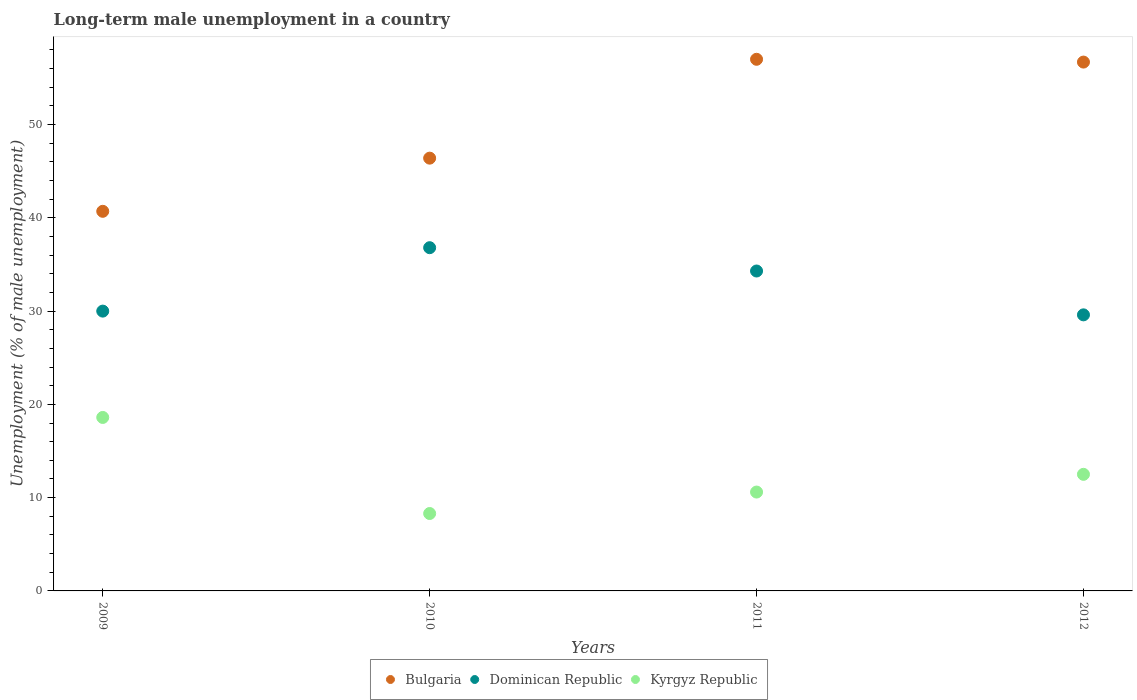How many different coloured dotlines are there?
Your answer should be compact. 3. Is the number of dotlines equal to the number of legend labels?
Provide a succinct answer. Yes. What is the percentage of long-term unemployed male population in Dominican Republic in 2012?
Provide a short and direct response. 29.6. Across all years, what is the maximum percentage of long-term unemployed male population in Kyrgyz Republic?
Your answer should be compact. 18.6. Across all years, what is the minimum percentage of long-term unemployed male population in Bulgaria?
Offer a very short reply. 40.7. In which year was the percentage of long-term unemployed male population in Kyrgyz Republic maximum?
Your answer should be very brief. 2009. In which year was the percentage of long-term unemployed male population in Kyrgyz Republic minimum?
Provide a short and direct response. 2010. What is the total percentage of long-term unemployed male population in Dominican Republic in the graph?
Your response must be concise. 130.7. What is the difference between the percentage of long-term unemployed male population in Dominican Republic in 2009 and that in 2012?
Make the answer very short. 0.4. What is the difference between the percentage of long-term unemployed male population in Dominican Republic in 2012 and the percentage of long-term unemployed male population in Bulgaria in 2009?
Provide a short and direct response. -11.1. What is the average percentage of long-term unemployed male population in Bulgaria per year?
Your answer should be compact. 50.2. In the year 2011, what is the difference between the percentage of long-term unemployed male population in Bulgaria and percentage of long-term unemployed male population in Kyrgyz Republic?
Your answer should be compact. 46.4. In how many years, is the percentage of long-term unemployed male population in Bulgaria greater than 14 %?
Offer a terse response. 4. What is the ratio of the percentage of long-term unemployed male population in Bulgaria in 2010 to that in 2011?
Your answer should be compact. 0.81. Is the percentage of long-term unemployed male population in Kyrgyz Republic in 2010 less than that in 2011?
Provide a succinct answer. Yes. Is the difference between the percentage of long-term unemployed male population in Bulgaria in 2010 and 2012 greater than the difference between the percentage of long-term unemployed male population in Kyrgyz Republic in 2010 and 2012?
Your response must be concise. No. What is the difference between the highest and the second highest percentage of long-term unemployed male population in Kyrgyz Republic?
Provide a succinct answer. 6.1. What is the difference between the highest and the lowest percentage of long-term unemployed male population in Kyrgyz Republic?
Provide a succinct answer. 10.3. Does the percentage of long-term unemployed male population in Kyrgyz Republic monotonically increase over the years?
Keep it short and to the point. No. Is the percentage of long-term unemployed male population in Dominican Republic strictly greater than the percentage of long-term unemployed male population in Kyrgyz Republic over the years?
Provide a succinct answer. Yes. Is the percentage of long-term unemployed male population in Dominican Republic strictly less than the percentage of long-term unemployed male population in Kyrgyz Republic over the years?
Make the answer very short. No. How many dotlines are there?
Give a very brief answer. 3. What is the difference between two consecutive major ticks on the Y-axis?
Offer a terse response. 10. Are the values on the major ticks of Y-axis written in scientific E-notation?
Your answer should be compact. No. Does the graph contain any zero values?
Your answer should be compact. No. Where does the legend appear in the graph?
Offer a very short reply. Bottom center. How many legend labels are there?
Your response must be concise. 3. How are the legend labels stacked?
Make the answer very short. Horizontal. What is the title of the graph?
Give a very brief answer. Long-term male unemployment in a country. Does "Senegal" appear as one of the legend labels in the graph?
Offer a very short reply. No. What is the label or title of the Y-axis?
Ensure brevity in your answer.  Unemployment (% of male unemployment). What is the Unemployment (% of male unemployment) of Bulgaria in 2009?
Make the answer very short. 40.7. What is the Unemployment (% of male unemployment) in Kyrgyz Republic in 2009?
Your answer should be very brief. 18.6. What is the Unemployment (% of male unemployment) of Bulgaria in 2010?
Provide a succinct answer. 46.4. What is the Unemployment (% of male unemployment) in Dominican Republic in 2010?
Offer a very short reply. 36.8. What is the Unemployment (% of male unemployment) in Kyrgyz Republic in 2010?
Your answer should be compact. 8.3. What is the Unemployment (% of male unemployment) in Dominican Republic in 2011?
Your response must be concise. 34.3. What is the Unemployment (% of male unemployment) in Kyrgyz Republic in 2011?
Provide a succinct answer. 10.6. What is the Unemployment (% of male unemployment) in Bulgaria in 2012?
Offer a very short reply. 56.7. What is the Unemployment (% of male unemployment) in Dominican Republic in 2012?
Keep it short and to the point. 29.6. Across all years, what is the maximum Unemployment (% of male unemployment) in Dominican Republic?
Offer a very short reply. 36.8. Across all years, what is the maximum Unemployment (% of male unemployment) in Kyrgyz Republic?
Offer a terse response. 18.6. Across all years, what is the minimum Unemployment (% of male unemployment) in Bulgaria?
Your answer should be compact. 40.7. Across all years, what is the minimum Unemployment (% of male unemployment) of Dominican Republic?
Your answer should be compact. 29.6. Across all years, what is the minimum Unemployment (% of male unemployment) in Kyrgyz Republic?
Your answer should be compact. 8.3. What is the total Unemployment (% of male unemployment) of Bulgaria in the graph?
Make the answer very short. 200.8. What is the total Unemployment (% of male unemployment) in Dominican Republic in the graph?
Ensure brevity in your answer.  130.7. What is the difference between the Unemployment (% of male unemployment) in Bulgaria in 2009 and that in 2010?
Ensure brevity in your answer.  -5.7. What is the difference between the Unemployment (% of male unemployment) in Kyrgyz Republic in 2009 and that in 2010?
Give a very brief answer. 10.3. What is the difference between the Unemployment (% of male unemployment) of Bulgaria in 2009 and that in 2011?
Your response must be concise. -16.3. What is the difference between the Unemployment (% of male unemployment) of Dominican Republic in 2009 and that in 2011?
Keep it short and to the point. -4.3. What is the difference between the Unemployment (% of male unemployment) in Bulgaria in 2009 and that in 2012?
Give a very brief answer. -16. What is the difference between the Unemployment (% of male unemployment) in Dominican Republic in 2009 and that in 2012?
Give a very brief answer. 0.4. What is the difference between the Unemployment (% of male unemployment) of Bulgaria in 2010 and that in 2011?
Offer a very short reply. -10.6. What is the difference between the Unemployment (% of male unemployment) of Dominican Republic in 2010 and that in 2012?
Your response must be concise. 7.2. What is the difference between the Unemployment (% of male unemployment) of Kyrgyz Republic in 2010 and that in 2012?
Ensure brevity in your answer.  -4.2. What is the difference between the Unemployment (% of male unemployment) of Kyrgyz Republic in 2011 and that in 2012?
Your answer should be compact. -1.9. What is the difference between the Unemployment (% of male unemployment) in Bulgaria in 2009 and the Unemployment (% of male unemployment) in Dominican Republic in 2010?
Offer a terse response. 3.9. What is the difference between the Unemployment (% of male unemployment) of Bulgaria in 2009 and the Unemployment (% of male unemployment) of Kyrgyz Republic in 2010?
Provide a succinct answer. 32.4. What is the difference between the Unemployment (% of male unemployment) of Dominican Republic in 2009 and the Unemployment (% of male unemployment) of Kyrgyz Republic in 2010?
Ensure brevity in your answer.  21.7. What is the difference between the Unemployment (% of male unemployment) of Bulgaria in 2009 and the Unemployment (% of male unemployment) of Dominican Republic in 2011?
Keep it short and to the point. 6.4. What is the difference between the Unemployment (% of male unemployment) in Bulgaria in 2009 and the Unemployment (% of male unemployment) in Kyrgyz Republic in 2011?
Give a very brief answer. 30.1. What is the difference between the Unemployment (% of male unemployment) of Dominican Republic in 2009 and the Unemployment (% of male unemployment) of Kyrgyz Republic in 2011?
Provide a succinct answer. 19.4. What is the difference between the Unemployment (% of male unemployment) in Bulgaria in 2009 and the Unemployment (% of male unemployment) in Dominican Republic in 2012?
Ensure brevity in your answer.  11.1. What is the difference between the Unemployment (% of male unemployment) in Bulgaria in 2009 and the Unemployment (% of male unemployment) in Kyrgyz Republic in 2012?
Offer a very short reply. 28.2. What is the difference between the Unemployment (% of male unemployment) in Bulgaria in 2010 and the Unemployment (% of male unemployment) in Dominican Republic in 2011?
Your answer should be very brief. 12.1. What is the difference between the Unemployment (% of male unemployment) of Bulgaria in 2010 and the Unemployment (% of male unemployment) of Kyrgyz Republic in 2011?
Your answer should be very brief. 35.8. What is the difference between the Unemployment (% of male unemployment) in Dominican Republic in 2010 and the Unemployment (% of male unemployment) in Kyrgyz Republic in 2011?
Ensure brevity in your answer.  26.2. What is the difference between the Unemployment (% of male unemployment) in Bulgaria in 2010 and the Unemployment (% of male unemployment) in Dominican Republic in 2012?
Keep it short and to the point. 16.8. What is the difference between the Unemployment (% of male unemployment) of Bulgaria in 2010 and the Unemployment (% of male unemployment) of Kyrgyz Republic in 2012?
Provide a succinct answer. 33.9. What is the difference between the Unemployment (% of male unemployment) in Dominican Republic in 2010 and the Unemployment (% of male unemployment) in Kyrgyz Republic in 2012?
Your response must be concise. 24.3. What is the difference between the Unemployment (% of male unemployment) in Bulgaria in 2011 and the Unemployment (% of male unemployment) in Dominican Republic in 2012?
Make the answer very short. 27.4. What is the difference between the Unemployment (% of male unemployment) in Bulgaria in 2011 and the Unemployment (% of male unemployment) in Kyrgyz Republic in 2012?
Your answer should be very brief. 44.5. What is the difference between the Unemployment (% of male unemployment) in Dominican Republic in 2011 and the Unemployment (% of male unemployment) in Kyrgyz Republic in 2012?
Ensure brevity in your answer.  21.8. What is the average Unemployment (% of male unemployment) in Bulgaria per year?
Make the answer very short. 50.2. What is the average Unemployment (% of male unemployment) in Dominican Republic per year?
Your response must be concise. 32.67. In the year 2009, what is the difference between the Unemployment (% of male unemployment) of Bulgaria and Unemployment (% of male unemployment) of Dominican Republic?
Your response must be concise. 10.7. In the year 2009, what is the difference between the Unemployment (% of male unemployment) of Bulgaria and Unemployment (% of male unemployment) of Kyrgyz Republic?
Your response must be concise. 22.1. In the year 2009, what is the difference between the Unemployment (% of male unemployment) in Dominican Republic and Unemployment (% of male unemployment) in Kyrgyz Republic?
Ensure brevity in your answer.  11.4. In the year 2010, what is the difference between the Unemployment (% of male unemployment) of Bulgaria and Unemployment (% of male unemployment) of Kyrgyz Republic?
Your response must be concise. 38.1. In the year 2010, what is the difference between the Unemployment (% of male unemployment) in Dominican Republic and Unemployment (% of male unemployment) in Kyrgyz Republic?
Your answer should be very brief. 28.5. In the year 2011, what is the difference between the Unemployment (% of male unemployment) of Bulgaria and Unemployment (% of male unemployment) of Dominican Republic?
Make the answer very short. 22.7. In the year 2011, what is the difference between the Unemployment (% of male unemployment) of Bulgaria and Unemployment (% of male unemployment) of Kyrgyz Republic?
Your answer should be very brief. 46.4. In the year 2011, what is the difference between the Unemployment (% of male unemployment) in Dominican Republic and Unemployment (% of male unemployment) in Kyrgyz Republic?
Your answer should be very brief. 23.7. In the year 2012, what is the difference between the Unemployment (% of male unemployment) in Bulgaria and Unemployment (% of male unemployment) in Dominican Republic?
Keep it short and to the point. 27.1. In the year 2012, what is the difference between the Unemployment (% of male unemployment) in Bulgaria and Unemployment (% of male unemployment) in Kyrgyz Republic?
Your response must be concise. 44.2. In the year 2012, what is the difference between the Unemployment (% of male unemployment) in Dominican Republic and Unemployment (% of male unemployment) in Kyrgyz Republic?
Offer a terse response. 17.1. What is the ratio of the Unemployment (% of male unemployment) in Bulgaria in 2009 to that in 2010?
Provide a succinct answer. 0.88. What is the ratio of the Unemployment (% of male unemployment) of Dominican Republic in 2009 to that in 2010?
Your answer should be very brief. 0.82. What is the ratio of the Unemployment (% of male unemployment) of Kyrgyz Republic in 2009 to that in 2010?
Make the answer very short. 2.24. What is the ratio of the Unemployment (% of male unemployment) in Bulgaria in 2009 to that in 2011?
Make the answer very short. 0.71. What is the ratio of the Unemployment (% of male unemployment) in Dominican Republic in 2009 to that in 2011?
Make the answer very short. 0.87. What is the ratio of the Unemployment (% of male unemployment) of Kyrgyz Republic in 2009 to that in 2011?
Keep it short and to the point. 1.75. What is the ratio of the Unemployment (% of male unemployment) in Bulgaria in 2009 to that in 2012?
Provide a succinct answer. 0.72. What is the ratio of the Unemployment (% of male unemployment) of Dominican Republic in 2009 to that in 2012?
Your answer should be compact. 1.01. What is the ratio of the Unemployment (% of male unemployment) in Kyrgyz Republic in 2009 to that in 2012?
Make the answer very short. 1.49. What is the ratio of the Unemployment (% of male unemployment) in Bulgaria in 2010 to that in 2011?
Offer a terse response. 0.81. What is the ratio of the Unemployment (% of male unemployment) in Dominican Republic in 2010 to that in 2011?
Make the answer very short. 1.07. What is the ratio of the Unemployment (% of male unemployment) in Kyrgyz Republic in 2010 to that in 2011?
Provide a short and direct response. 0.78. What is the ratio of the Unemployment (% of male unemployment) in Bulgaria in 2010 to that in 2012?
Your answer should be very brief. 0.82. What is the ratio of the Unemployment (% of male unemployment) of Dominican Republic in 2010 to that in 2012?
Your answer should be compact. 1.24. What is the ratio of the Unemployment (% of male unemployment) of Kyrgyz Republic in 2010 to that in 2012?
Provide a succinct answer. 0.66. What is the ratio of the Unemployment (% of male unemployment) of Dominican Republic in 2011 to that in 2012?
Ensure brevity in your answer.  1.16. What is the ratio of the Unemployment (% of male unemployment) in Kyrgyz Republic in 2011 to that in 2012?
Keep it short and to the point. 0.85. What is the difference between the highest and the second highest Unemployment (% of male unemployment) of Dominican Republic?
Provide a succinct answer. 2.5. What is the difference between the highest and the second highest Unemployment (% of male unemployment) of Kyrgyz Republic?
Give a very brief answer. 6.1. What is the difference between the highest and the lowest Unemployment (% of male unemployment) in Dominican Republic?
Your response must be concise. 7.2. 